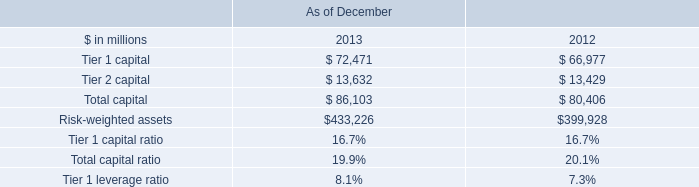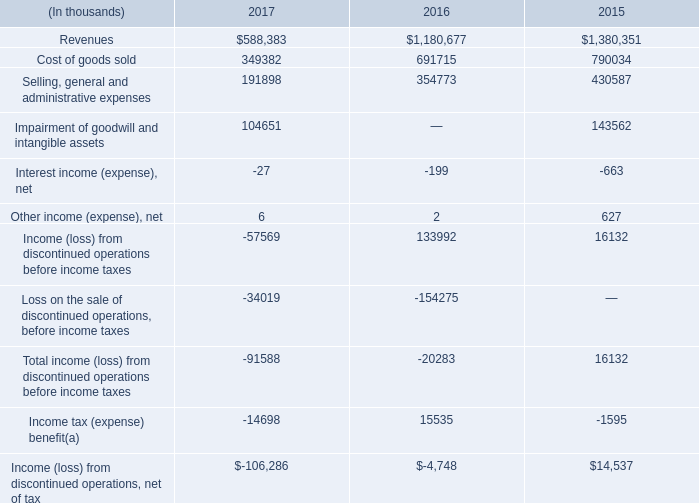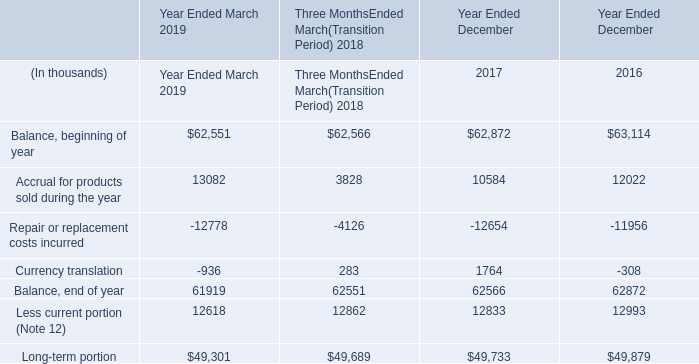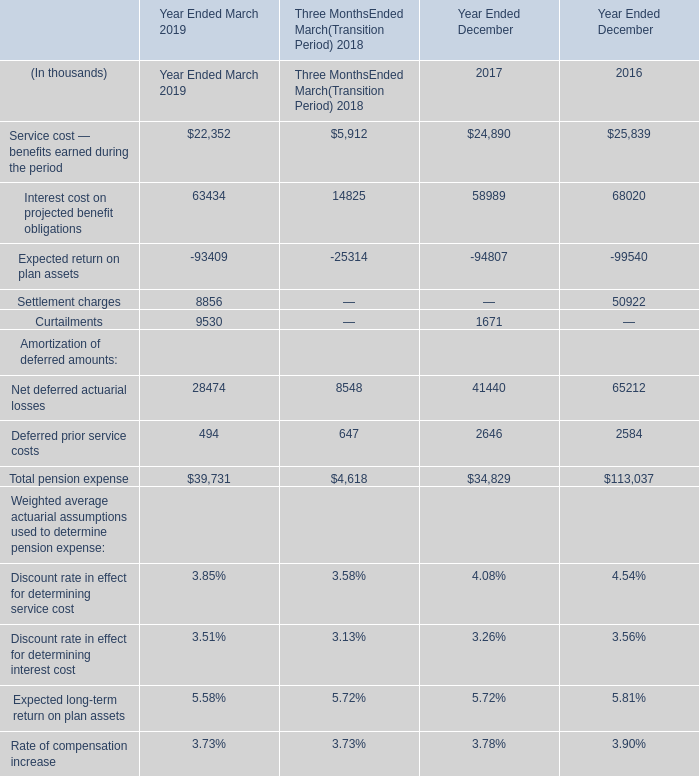If Less current portion (Note 12) develops with the same increasing rate in 2019, what will it reach in 2020? (in thousand) 
Computations: ((((12618 - 12862) / 12862) + 1) * 12618)
Answer: 12378.62883. 